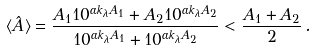<formula> <loc_0><loc_0><loc_500><loc_500>\langle \hat { A } \rangle = \frac { A _ { 1 } 1 0 ^ { \alpha k _ { \lambda } A _ { 1 } } + A _ { 2 } 1 0 ^ { \alpha k _ { \lambda } A _ { 2 } } } { 1 0 ^ { \alpha k _ { \lambda } A _ { 1 } } + 1 0 ^ { \alpha k _ { \lambda } A _ { 2 } } } < \frac { A _ { 1 } + A _ { 2 } } { 2 } \, .</formula> 